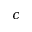<formula> <loc_0><loc_0><loc_500><loc_500>c</formula> 